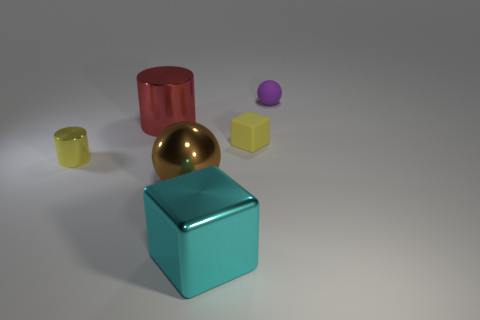What number of blue objects are big blocks or large metallic cylinders?
Your answer should be compact. 0. The thing that is behind the yellow block and in front of the purple matte object is what color?
Your answer should be very brief. Red. Is the material of the yellow object in front of the tiny cube the same as the sphere in front of the big cylinder?
Make the answer very short. Yes. Are there more objects that are in front of the tiny matte block than large cyan objects on the right side of the purple matte ball?
Give a very brief answer. Yes. What shape is the cyan object that is the same size as the brown metallic ball?
Your response must be concise. Cube. How many objects are either cyan metallic balls or large metal things on the left side of the metallic block?
Provide a succinct answer. 2. Do the tiny cylinder and the rubber cube have the same color?
Your answer should be compact. Yes. There is a small purple thing; what number of large brown shiny spheres are right of it?
Your response must be concise. 0. What is the color of the big cube that is the same material as the large brown object?
Provide a succinct answer. Cyan. How many matte things are large blue blocks or tiny purple things?
Ensure brevity in your answer.  1. 